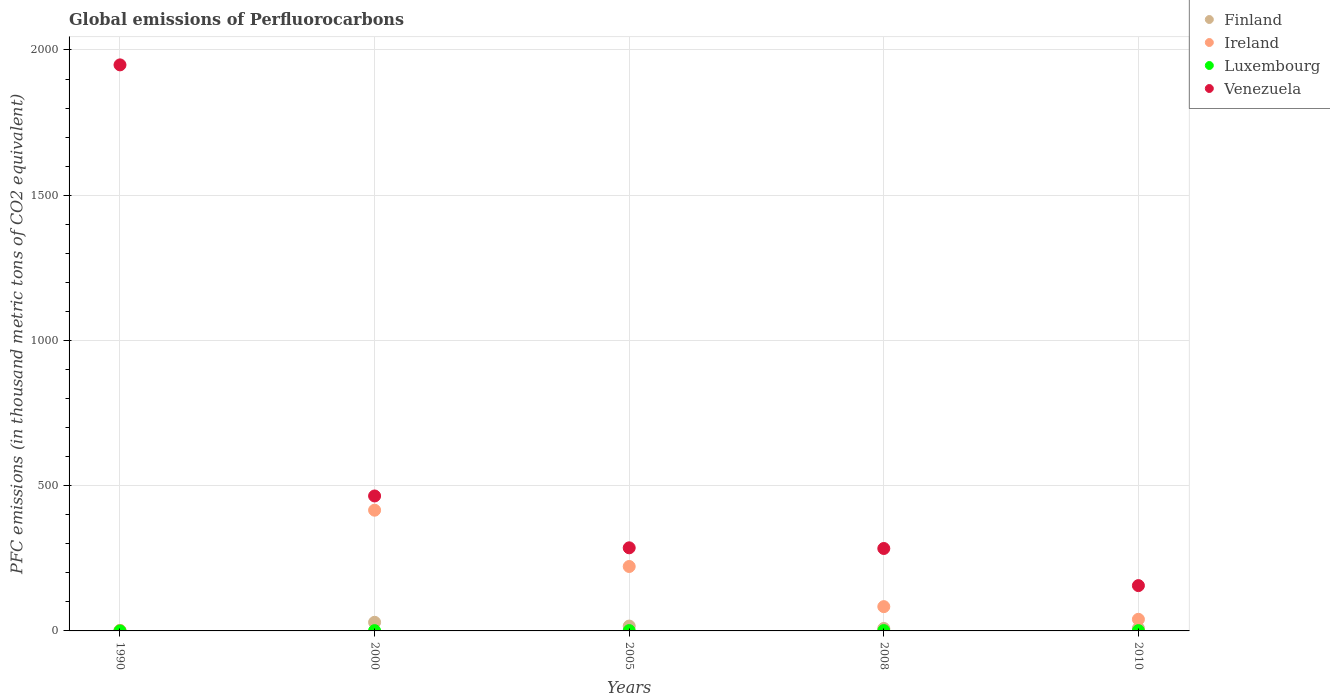What is the global emissions of Perfluorocarbons in Venezuela in 2010?
Keep it short and to the point. 156. Across all years, what is the maximum global emissions of Perfluorocarbons in Ireland?
Give a very brief answer. 415.6. In which year was the global emissions of Perfluorocarbons in Finland maximum?
Give a very brief answer. 2000. What is the total global emissions of Perfluorocarbons in Ireland in the graph?
Offer a terse response. 762.4. What is the difference between the global emissions of Perfluorocarbons in Luxembourg in 2000 and that in 2010?
Your response must be concise. 0. What is the difference between the global emissions of Perfluorocarbons in Venezuela in 2000 and the global emissions of Perfluorocarbons in Luxembourg in 1990?
Offer a very short reply. 464.5. What is the average global emissions of Perfluorocarbons in Finland per year?
Your answer should be very brief. 13.1. In how many years, is the global emissions of Perfluorocarbons in Venezuela greater than 400 thousand metric tons?
Keep it short and to the point. 2. What is the ratio of the global emissions of Perfluorocarbons in Venezuela in 2005 to that in 2010?
Offer a terse response. 1.83. What is the difference between the highest and the second highest global emissions of Perfluorocarbons in Luxembourg?
Give a very brief answer. 0.1. What is the difference between the highest and the lowest global emissions of Perfluorocarbons in Ireland?
Your answer should be very brief. 414.2. In how many years, is the global emissions of Perfluorocarbons in Ireland greater than the average global emissions of Perfluorocarbons in Ireland taken over all years?
Give a very brief answer. 2. Is it the case that in every year, the sum of the global emissions of Perfluorocarbons in Finland and global emissions of Perfluorocarbons in Ireland  is greater than the global emissions of Perfluorocarbons in Venezuela?
Ensure brevity in your answer.  No. How many dotlines are there?
Give a very brief answer. 4. What is the difference between two consecutive major ticks on the Y-axis?
Your answer should be very brief. 500. Are the values on the major ticks of Y-axis written in scientific E-notation?
Provide a succinct answer. No. Does the graph contain grids?
Ensure brevity in your answer.  Yes. Where does the legend appear in the graph?
Offer a terse response. Top right. How many legend labels are there?
Your answer should be compact. 4. How are the legend labels stacked?
Give a very brief answer. Vertical. What is the title of the graph?
Provide a succinct answer. Global emissions of Perfluorocarbons. What is the label or title of the Y-axis?
Provide a succinct answer. PFC emissions (in thousand metric tons of CO2 equivalent). What is the PFC emissions (in thousand metric tons of CO2 equivalent) of Luxembourg in 1990?
Provide a short and direct response. 0.1. What is the PFC emissions (in thousand metric tons of CO2 equivalent) in Venezuela in 1990?
Give a very brief answer. 1948.7. What is the PFC emissions (in thousand metric tons of CO2 equivalent) of Finland in 2000?
Keep it short and to the point. 29.7. What is the PFC emissions (in thousand metric tons of CO2 equivalent) in Ireland in 2000?
Your response must be concise. 415.6. What is the PFC emissions (in thousand metric tons of CO2 equivalent) in Venezuela in 2000?
Your answer should be very brief. 464.6. What is the PFC emissions (in thousand metric tons of CO2 equivalent) in Finland in 2005?
Your answer should be very brief. 16.7. What is the PFC emissions (in thousand metric tons of CO2 equivalent) of Ireland in 2005?
Offer a terse response. 221.8. What is the PFC emissions (in thousand metric tons of CO2 equivalent) in Venezuela in 2005?
Make the answer very short. 286.1. What is the PFC emissions (in thousand metric tons of CO2 equivalent) of Finland in 2008?
Make the answer very short. 8.4. What is the PFC emissions (in thousand metric tons of CO2 equivalent) in Ireland in 2008?
Your response must be concise. 83.6. What is the PFC emissions (in thousand metric tons of CO2 equivalent) of Luxembourg in 2008?
Make the answer very short. 1.2. What is the PFC emissions (in thousand metric tons of CO2 equivalent) of Venezuela in 2008?
Keep it short and to the point. 283.8. What is the PFC emissions (in thousand metric tons of CO2 equivalent) in Finland in 2010?
Provide a succinct answer. 9. What is the PFC emissions (in thousand metric tons of CO2 equivalent) in Ireland in 2010?
Your answer should be very brief. 40. What is the PFC emissions (in thousand metric tons of CO2 equivalent) in Venezuela in 2010?
Provide a succinct answer. 156. Across all years, what is the maximum PFC emissions (in thousand metric tons of CO2 equivalent) of Finland?
Provide a short and direct response. 29.7. Across all years, what is the maximum PFC emissions (in thousand metric tons of CO2 equivalent) of Ireland?
Offer a terse response. 415.6. Across all years, what is the maximum PFC emissions (in thousand metric tons of CO2 equivalent) of Luxembourg?
Provide a succinct answer. 1.2. Across all years, what is the maximum PFC emissions (in thousand metric tons of CO2 equivalent) in Venezuela?
Your response must be concise. 1948.7. Across all years, what is the minimum PFC emissions (in thousand metric tons of CO2 equivalent) of Finland?
Offer a very short reply. 1.7. Across all years, what is the minimum PFC emissions (in thousand metric tons of CO2 equivalent) in Luxembourg?
Keep it short and to the point. 0.1. Across all years, what is the minimum PFC emissions (in thousand metric tons of CO2 equivalent) in Venezuela?
Ensure brevity in your answer.  156. What is the total PFC emissions (in thousand metric tons of CO2 equivalent) in Finland in the graph?
Provide a short and direct response. 65.5. What is the total PFC emissions (in thousand metric tons of CO2 equivalent) in Ireland in the graph?
Keep it short and to the point. 762.4. What is the total PFC emissions (in thousand metric tons of CO2 equivalent) of Venezuela in the graph?
Provide a succinct answer. 3139.2. What is the difference between the PFC emissions (in thousand metric tons of CO2 equivalent) of Ireland in 1990 and that in 2000?
Keep it short and to the point. -414.2. What is the difference between the PFC emissions (in thousand metric tons of CO2 equivalent) in Luxembourg in 1990 and that in 2000?
Ensure brevity in your answer.  -0.9. What is the difference between the PFC emissions (in thousand metric tons of CO2 equivalent) of Venezuela in 1990 and that in 2000?
Offer a terse response. 1484.1. What is the difference between the PFC emissions (in thousand metric tons of CO2 equivalent) in Finland in 1990 and that in 2005?
Make the answer very short. -15. What is the difference between the PFC emissions (in thousand metric tons of CO2 equivalent) of Ireland in 1990 and that in 2005?
Provide a succinct answer. -220.4. What is the difference between the PFC emissions (in thousand metric tons of CO2 equivalent) in Luxembourg in 1990 and that in 2005?
Offer a very short reply. -1. What is the difference between the PFC emissions (in thousand metric tons of CO2 equivalent) in Venezuela in 1990 and that in 2005?
Offer a terse response. 1662.6. What is the difference between the PFC emissions (in thousand metric tons of CO2 equivalent) of Ireland in 1990 and that in 2008?
Ensure brevity in your answer.  -82.2. What is the difference between the PFC emissions (in thousand metric tons of CO2 equivalent) in Venezuela in 1990 and that in 2008?
Ensure brevity in your answer.  1664.9. What is the difference between the PFC emissions (in thousand metric tons of CO2 equivalent) in Ireland in 1990 and that in 2010?
Make the answer very short. -38.6. What is the difference between the PFC emissions (in thousand metric tons of CO2 equivalent) of Venezuela in 1990 and that in 2010?
Keep it short and to the point. 1792.7. What is the difference between the PFC emissions (in thousand metric tons of CO2 equivalent) in Ireland in 2000 and that in 2005?
Your answer should be compact. 193.8. What is the difference between the PFC emissions (in thousand metric tons of CO2 equivalent) in Luxembourg in 2000 and that in 2005?
Offer a terse response. -0.1. What is the difference between the PFC emissions (in thousand metric tons of CO2 equivalent) in Venezuela in 2000 and that in 2005?
Your answer should be compact. 178.5. What is the difference between the PFC emissions (in thousand metric tons of CO2 equivalent) of Finland in 2000 and that in 2008?
Offer a terse response. 21.3. What is the difference between the PFC emissions (in thousand metric tons of CO2 equivalent) of Ireland in 2000 and that in 2008?
Offer a very short reply. 332. What is the difference between the PFC emissions (in thousand metric tons of CO2 equivalent) of Luxembourg in 2000 and that in 2008?
Provide a succinct answer. -0.2. What is the difference between the PFC emissions (in thousand metric tons of CO2 equivalent) in Venezuela in 2000 and that in 2008?
Ensure brevity in your answer.  180.8. What is the difference between the PFC emissions (in thousand metric tons of CO2 equivalent) of Finland in 2000 and that in 2010?
Keep it short and to the point. 20.7. What is the difference between the PFC emissions (in thousand metric tons of CO2 equivalent) of Ireland in 2000 and that in 2010?
Make the answer very short. 375.6. What is the difference between the PFC emissions (in thousand metric tons of CO2 equivalent) in Venezuela in 2000 and that in 2010?
Your answer should be very brief. 308.6. What is the difference between the PFC emissions (in thousand metric tons of CO2 equivalent) of Finland in 2005 and that in 2008?
Provide a succinct answer. 8.3. What is the difference between the PFC emissions (in thousand metric tons of CO2 equivalent) in Ireland in 2005 and that in 2008?
Offer a terse response. 138.2. What is the difference between the PFC emissions (in thousand metric tons of CO2 equivalent) in Venezuela in 2005 and that in 2008?
Keep it short and to the point. 2.3. What is the difference between the PFC emissions (in thousand metric tons of CO2 equivalent) of Finland in 2005 and that in 2010?
Offer a terse response. 7.7. What is the difference between the PFC emissions (in thousand metric tons of CO2 equivalent) of Ireland in 2005 and that in 2010?
Offer a terse response. 181.8. What is the difference between the PFC emissions (in thousand metric tons of CO2 equivalent) of Luxembourg in 2005 and that in 2010?
Give a very brief answer. 0.1. What is the difference between the PFC emissions (in thousand metric tons of CO2 equivalent) in Venezuela in 2005 and that in 2010?
Make the answer very short. 130.1. What is the difference between the PFC emissions (in thousand metric tons of CO2 equivalent) in Ireland in 2008 and that in 2010?
Offer a very short reply. 43.6. What is the difference between the PFC emissions (in thousand metric tons of CO2 equivalent) in Venezuela in 2008 and that in 2010?
Make the answer very short. 127.8. What is the difference between the PFC emissions (in thousand metric tons of CO2 equivalent) of Finland in 1990 and the PFC emissions (in thousand metric tons of CO2 equivalent) of Ireland in 2000?
Offer a terse response. -413.9. What is the difference between the PFC emissions (in thousand metric tons of CO2 equivalent) of Finland in 1990 and the PFC emissions (in thousand metric tons of CO2 equivalent) of Venezuela in 2000?
Offer a terse response. -462.9. What is the difference between the PFC emissions (in thousand metric tons of CO2 equivalent) of Ireland in 1990 and the PFC emissions (in thousand metric tons of CO2 equivalent) of Luxembourg in 2000?
Make the answer very short. 0.4. What is the difference between the PFC emissions (in thousand metric tons of CO2 equivalent) in Ireland in 1990 and the PFC emissions (in thousand metric tons of CO2 equivalent) in Venezuela in 2000?
Offer a very short reply. -463.2. What is the difference between the PFC emissions (in thousand metric tons of CO2 equivalent) in Luxembourg in 1990 and the PFC emissions (in thousand metric tons of CO2 equivalent) in Venezuela in 2000?
Make the answer very short. -464.5. What is the difference between the PFC emissions (in thousand metric tons of CO2 equivalent) of Finland in 1990 and the PFC emissions (in thousand metric tons of CO2 equivalent) of Ireland in 2005?
Your answer should be very brief. -220.1. What is the difference between the PFC emissions (in thousand metric tons of CO2 equivalent) in Finland in 1990 and the PFC emissions (in thousand metric tons of CO2 equivalent) in Venezuela in 2005?
Your response must be concise. -284.4. What is the difference between the PFC emissions (in thousand metric tons of CO2 equivalent) in Ireland in 1990 and the PFC emissions (in thousand metric tons of CO2 equivalent) in Luxembourg in 2005?
Your response must be concise. 0.3. What is the difference between the PFC emissions (in thousand metric tons of CO2 equivalent) in Ireland in 1990 and the PFC emissions (in thousand metric tons of CO2 equivalent) in Venezuela in 2005?
Give a very brief answer. -284.7. What is the difference between the PFC emissions (in thousand metric tons of CO2 equivalent) of Luxembourg in 1990 and the PFC emissions (in thousand metric tons of CO2 equivalent) of Venezuela in 2005?
Ensure brevity in your answer.  -286. What is the difference between the PFC emissions (in thousand metric tons of CO2 equivalent) of Finland in 1990 and the PFC emissions (in thousand metric tons of CO2 equivalent) of Ireland in 2008?
Ensure brevity in your answer.  -81.9. What is the difference between the PFC emissions (in thousand metric tons of CO2 equivalent) in Finland in 1990 and the PFC emissions (in thousand metric tons of CO2 equivalent) in Luxembourg in 2008?
Make the answer very short. 0.5. What is the difference between the PFC emissions (in thousand metric tons of CO2 equivalent) in Finland in 1990 and the PFC emissions (in thousand metric tons of CO2 equivalent) in Venezuela in 2008?
Provide a succinct answer. -282.1. What is the difference between the PFC emissions (in thousand metric tons of CO2 equivalent) in Ireland in 1990 and the PFC emissions (in thousand metric tons of CO2 equivalent) in Luxembourg in 2008?
Offer a terse response. 0.2. What is the difference between the PFC emissions (in thousand metric tons of CO2 equivalent) of Ireland in 1990 and the PFC emissions (in thousand metric tons of CO2 equivalent) of Venezuela in 2008?
Ensure brevity in your answer.  -282.4. What is the difference between the PFC emissions (in thousand metric tons of CO2 equivalent) of Luxembourg in 1990 and the PFC emissions (in thousand metric tons of CO2 equivalent) of Venezuela in 2008?
Provide a short and direct response. -283.7. What is the difference between the PFC emissions (in thousand metric tons of CO2 equivalent) of Finland in 1990 and the PFC emissions (in thousand metric tons of CO2 equivalent) of Ireland in 2010?
Give a very brief answer. -38.3. What is the difference between the PFC emissions (in thousand metric tons of CO2 equivalent) of Finland in 1990 and the PFC emissions (in thousand metric tons of CO2 equivalent) of Venezuela in 2010?
Offer a terse response. -154.3. What is the difference between the PFC emissions (in thousand metric tons of CO2 equivalent) in Ireland in 1990 and the PFC emissions (in thousand metric tons of CO2 equivalent) in Venezuela in 2010?
Offer a very short reply. -154.6. What is the difference between the PFC emissions (in thousand metric tons of CO2 equivalent) in Luxembourg in 1990 and the PFC emissions (in thousand metric tons of CO2 equivalent) in Venezuela in 2010?
Provide a short and direct response. -155.9. What is the difference between the PFC emissions (in thousand metric tons of CO2 equivalent) of Finland in 2000 and the PFC emissions (in thousand metric tons of CO2 equivalent) of Ireland in 2005?
Offer a terse response. -192.1. What is the difference between the PFC emissions (in thousand metric tons of CO2 equivalent) of Finland in 2000 and the PFC emissions (in thousand metric tons of CO2 equivalent) of Luxembourg in 2005?
Make the answer very short. 28.6. What is the difference between the PFC emissions (in thousand metric tons of CO2 equivalent) of Finland in 2000 and the PFC emissions (in thousand metric tons of CO2 equivalent) of Venezuela in 2005?
Give a very brief answer. -256.4. What is the difference between the PFC emissions (in thousand metric tons of CO2 equivalent) in Ireland in 2000 and the PFC emissions (in thousand metric tons of CO2 equivalent) in Luxembourg in 2005?
Provide a succinct answer. 414.5. What is the difference between the PFC emissions (in thousand metric tons of CO2 equivalent) of Ireland in 2000 and the PFC emissions (in thousand metric tons of CO2 equivalent) of Venezuela in 2005?
Ensure brevity in your answer.  129.5. What is the difference between the PFC emissions (in thousand metric tons of CO2 equivalent) of Luxembourg in 2000 and the PFC emissions (in thousand metric tons of CO2 equivalent) of Venezuela in 2005?
Give a very brief answer. -285.1. What is the difference between the PFC emissions (in thousand metric tons of CO2 equivalent) of Finland in 2000 and the PFC emissions (in thousand metric tons of CO2 equivalent) of Ireland in 2008?
Your response must be concise. -53.9. What is the difference between the PFC emissions (in thousand metric tons of CO2 equivalent) in Finland in 2000 and the PFC emissions (in thousand metric tons of CO2 equivalent) in Luxembourg in 2008?
Provide a succinct answer. 28.5. What is the difference between the PFC emissions (in thousand metric tons of CO2 equivalent) of Finland in 2000 and the PFC emissions (in thousand metric tons of CO2 equivalent) of Venezuela in 2008?
Offer a very short reply. -254.1. What is the difference between the PFC emissions (in thousand metric tons of CO2 equivalent) in Ireland in 2000 and the PFC emissions (in thousand metric tons of CO2 equivalent) in Luxembourg in 2008?
Provide a short and direct response. 414.4. What is the difference between the PFC emissions (in thousand metric tons of CO2 equivalent) of Ireland in 2000 and the PFC emissions (in thousand metric tons of CO2 equivalent) of Venezuela in 2008?
Ensure brevity in your answer.  131.8. What is the difference between the PFC emissions (in thousand metric tons of CO2 equivalent) in Luxembourg in 2000 and the PFC emissions (in thousand metric tons of CO2 equivalent) in Venezuela in 2008?
Provide a short and direct response. -282.8. What is the difference between the PFC emissions (in thousand metric tons of CO2 equivalent) in Finland in 2000 and the PFC emissions (in thousand metric tons of CO2 equivalent) in Ireland in 2010?
Offer a very short reply. -10.3. What is the difference between the PFC emissions (in thousand metric tons of CO2 equivalent) of Finland in 2000 and the PFC emissions (in thousand metric tons of CO2 equivalent) of Luxembourg in 2010?
Ensure brevity in your answer.  28.7. What is the difference between the PFC emissions (in thousand metric tons of CO2 equivalent) in Finland in 2000 and the PFC emissions (in thousand metric tons of CO2 equivalent) in Venezuela in 2010?
Give a very brief answer. -126.3. What is the difference between the PFC emissions (in thousand metric tons of CO2 equivalent) in Ireland in 2000 and the PFC emissions (in thousand metric tons of CO2 equivalent) in Luxembourg in 2010?
Make the answer very short. 414.6. What is the difference between the PFC emissions (in thousand metric tons of CO2 equivalent) in Ireland in 2000 and the PFC emissions (in thousand metric tons of CO2 equivalent) in Venezuela in 2010?
Your answer should be very brief. 259.6. What is the difference between the PFC emissions (in thousand metric tons of CO2 equivalent) in Luxembourg in 2000 and the PFC emissions (in thousand metric tons of CO2 equivalent) in Venezuela in 2010?
Offer a very short reply. -155. What is the difference between the PFC emissions (in thousand metric tons of CO2 equivalent) in Finland in 2005 and the PFC emissions (in thousand metric tons of CO2 equivalent) in Ireland in 2008?
Offer a very short reply. -66.9. What is the difference between the PFC emissions (in thousand metric tons of CO2 equivalent) of Finland in 2005 and the PFC emissions (in thousand metric tons of CO2 equivalent) of Luxembourg in 2008?
Provide a succinct answer. 15.5. What is the difference between the PFC emissions (in thousand metric tons of CO2 equivalent) in Finland in 2005 and the PFC emissions (in thousand metric tons of CO2 equivalent) in Venezuela in 2008?
Ensure brevity in your answer.  -267.1. What is the difference between the PFC emissions (in thousand metric tons of CO2 equivalent) in Ireland in 2005 and the PFC emissions (in thousand metric tons of CO2 equivalent) in Luxembourg in 2008?
Make the answer very short. 220.6. What is the difference between the PFC emissions (in thousand metric tons of CO2 equivalent) in Ireland in 2005 and the PFC emissions (in thousand metric tons of CO2 equivalent) in Venezuela in 2008?
Offer a terse response. -62. What is the difference between the PFC emissions (in thousand metric tons of CO2 equivalent) in Luxembourg in 2005 and the PFC emissions (in thousand metric tons of CO2 equivalent) in Venezuela in 2008?
Offer a very short reply. -282.7. What is the difference between the PFC emissions (in thousand metric tons of CO2 equivalent) in Finland in 2005 and the PFC emissions (in thousand metric tons of CO2 equivalent) in Ireland in 2010?
Your response must be concise. -23.3. What is the difference between the PFC emissions (in thousand metric tons of CO2 equivalent) of Finland in 2005 and the PFC emissions (in thousand metric tons of CO2 equivalent) of Luxembourg in 2010?
Keep it short and to the point. 15.7. What is the difference between the PFC emissions (in thousand metric tons of CO2 equivalent) in Finland in 2005 and the PFC emissions (in thousand metric tons of CO2 equivalent) in Venezuela in 2010?
Give a very brief answer. -139.3. What is the difference between the PFC emissions (in thousand metric tons of CO2 equivalent) in Ireland in 2005 and the PFC emissions (in thousand metric tons of CO2 equivalent) in Luxembourg in 2010?
Your answer should be compact. 220.8. What is the difference between the PFC emissions (in thousand metric tons of CO2 equivalent) in Ireland in 2005 and the PFC emissions (in thousand metric tons of CO2 equivalent) in Venezuela in 2010?
Offer a terse response. 65.8. What is the difference between the PFC emissions (in thousand metric tons of CO2 equivalent) of Luxembourg in 2005 and the PFC emissions (in thousand metric tons of CO2 equivalent) of Venezuela in 2010?
Ensure brevity in your answer.  -154.9. What is the difference between the PFC emissions (in thousand metric tons of CO2 equivalent) in Finland in 2008 and the PFC emissions (in thousand metric tons of CO2 equivalent) in Ireland in 2010?
Provide a succinct answer. -31.6. What is the difference between the PFC emissions (in thousand metric tons of CO2 equivalent) of Finland in 2008 and the PFC emissions (in thousand metric tons of CO2 equivalent) of Venezuela in 2010?
Provide a succinct answer. -147.6. What is the difference between the PFC emissions (in thousand metric tons of CO2 equivalent) in Ireland in 2008 and the PFC emissions (in thousand metric tons of CO2 equivalent) in Luxembourg in 2010?
Your answer should be compact. 82.6. What is the difference between the PFC emissions (in thousand metric tons of CO2 equivalent) in Ireland in 2008 and the PFC emissions (in thousand metric tons of CO2 equivalent) in Venezuela in 2010?
Offer a very short reply. -72.4. What is the difference between the PFC emissions (in thousand metric tons of CO2 equivalent) in Luxembourg in 2008 and the PFC emissions (in thousand metric tons of CO2 equivalent) in Venezuela in 2010?
Offer a very short reply. -154.8. What is the average PFC emissions (in thousand metric tons of CO2 equivalent) in Ireland per year?
Your response must be concise. 152.48. What is the average PFC emissions (in thousand metric tons of CO2 equivalent) in Venezuela per year?
Your answer should be compact. 627.84. In the year 1990, what is the difference between the PFC emissions (in thousand metric tons of CO2 equivalent) of Finland and PFC emissions (in thousand metric tons of CO2 equivalent) of Ireland?
Keep it short and to the point. 0.3. In the year 1990, what is the difference between the PFC emissions (in thousand metric tons of CO2 equivalent) of Finland and PFC emissions (in thousand metric tons of CO2 equivalent) of Venezuela?
Your answer should be compact. -1947. In the year 1990, what is the difference between the PFC emissions (in thousand metric tons of CO2 equivalent) in Ireland and PFC emissions (in thousand metric tons of CO2 equivalent) in Venezuela?
Offer a very short reply. -1947.3. In the year 1990, what is the difference between the PFC emissions (in thousand metric tons of CO2 equivalent) in Luxembourg and PFC emissions (in thousand metric tons of CO2 equivalent) in Venezuela?
Keep it short and to the point. -1948.6. In the year 2000, what is the difference between the PFC emissions (in thousand metric tons of CO2 equivalent) of Finland and PFC emissions (in thousand metric tons of CO2 equivalent) of Ireland?
Provide a succinct answer. -385.9. In the year 2000, what is the difference between the PFC emissions (in thousand metric tons of CO2 equivalent) of Finland and PFC emissions (in thousand metric tons of CO2 equivalent) of Luxembourg?
Make the answer very short. 28.7. In the year 2000, what is the difference between the PFC emissions (in thousand metric tons of CO2 equivalent) of Finland and PFC emissions (in thousand metric tons of CO2 equivalent) of Venezuela?
Keep it short and to the point. -434.9. In the year 2000, what is the difference between the PFC emissions (in thousand metric tons of CO2 equivalent) of Ireland and PFC emissions (in thousand metric tons of CO2 equivalent) of Luxembourg?
Your response must be concise. 414.6. In the year 2000, what is the difference between the PFC emissions (in thousand metric tons of CO2 equivalent) in Ireland and PFC emissions (in thousand metric tons of CO2 equivalent) in Venezuela?
Provide a short and direct response. -49. In the year 2000, what is the difference between the PFC emissions (in thousand metric tons of CO2 equivalent) in Luxembourg and PFC emissions (in thousand metric tons of CO2 equivalent) in Venezuela?
Provide a short and direct response. -463.6. In the year 2005, what is the difference between the PFC emissions (in thousand metric tons of CO2 equivalent) of Finland and PFC emissions (in thousand metric tons of CO2 equivalent) of Ireland?
Ensure brevity in your answer.  -205.1. In the year 2005, what is the difference between the PFC emissions (in thousand metric tons of CO2 equivalent) in Finland and PFC emissions (in thousand metric tons of CO2 equivalent) in Venezuela?
Offer a terse response. -269.4. In the year 2005, what is the difference between the PFC emissions (in thousand metric tons of CO2 equivalent) of Ireland and PFC emissions (in thousand metric tons of CO2 equivalent) of Luxembourg?
Keep it short and to the point. 220.7. In the year 2005, what is the difference between the PFC emissions (in thousand metric tons of CO2 equivalent) of Ireland and PFC emissions (in thousand metric tons of CO2 equivalent) of Venezuela?
Your response must be concise. -64.3. In the year 2005, what is the difference between the PFC emissions (in thousand metric tons of CO2 equivalent) in Luxembourg and PFC emissions (in thousand metric tons of CO2 equivalent) in Venezuela?
Make the answer very short. -285. In the year 2008, what is the difference between the PFC emissions (in thousand metric tons of CO2 equivalent) in Finland and PFC emissions (in thousand metric tons of CO2 equivalent) in Ireland?
Keep it short and to the point. -75.2. In the year 2008, what is the difference between the PFC emissions (in thousand metric tons of CO2 equivalent) of Finland and PFC emissions (in thousand metric tons of CO2 equivalent) of Luxembourg?
Your answer should be compact. 7.2. In the year 2008, what is the difference between the PFC emissions (in thousand metric tons of CO2 equivalent) in Finland and PFC emissions (in thousand metric tons of CO2 equivalent) in Venezuela?
Your response must be concise. -275.4. In the year 2008, what is the difference between the PFC emissions (in thousand metric tons of CO2 equivalent) in Ireland and PFC emissions (in thousand metric tons of CO2 equivalent) in Luxembourg?
Offer a terse response. 82.4. In the year 2008, what is the difference between the PFC emissions (in thousand metric tons of CO2 equivalent) in Ireland and PFC emissions (in thousand metric tons of CO2 equivalent) in Venezuela?
Offer a terse response. -200.2. In the year 2008, what is the difference between the PFC emissions (in thousand metric tons of CO2 equivalent) of Luxembourg and PFC emissions (in thousand metric tons of CO2 equivalent) of Venezuela?
Ensure brevity in your answer.  -282.6. In the year 2010, what is the difference between the PFC emissions (in thousand metric tons of CO2 equivalent) of Finland and PFC emissions (in thousand metric tons of CO2 equivalent) of Ireland?
Make the answer very short. -31. In the year 2010, what is the difference between the PFC emissions (in thousand metric tons of CO2 equivalent) of Finland and PFC emissions (in thousand metric tons of CO2 equivalent) of Venezuela?
Provide a succinct answer. -147. In the year 2010, what is the difference between the PFC emissions (in thousand metric tons of CO2 equivalent) in Ireland and PFC emissions (in thousand metric tons of CO2 equivalent) in Venezuela?
Provide a succinct answer. -116. In the year 2010, what is the difference between the PFC emissions (in thousand metric tons of CO2 equivalent) in Luxembourg and PFC emissions (in thousand metric tons of CO2 equivalent) in Venezuela?
Give a very brief answer. -155. What is the ratio of the PFC emissions (in thousand metric tons of CO2 equivalent) of Finland in 1990 to that in 2000?
Keep it short and to the point. 0.06. What is the ratio of the PFC emissions (in thousand metric tons of CO2 equivalent) of Ireland in 1990 to that in 2000?
Your answer should be very brief. 0. What is the ratio of the PFC emissions (in thousand metric tons of CO2 equivalent) in Venezuela in 1990 to that in 2000?
Offer a terse response. 4.19. What is the ratio of the PFC emissions (in thousand metric tons of CO2 equivalent) of Finland in 1990 to that in 2005?
Your answer should be compact. 0.1. What is the ratio of the PFC emissions (in thousand metric tons of CO2 equivalent) of Ireland in 1990 to that in 2005?
Offer a very short reply. 0.01. What is the ratio of the PFC emissions (in thousand metric tons of CO2 equivalent) in Luxembourg in 1990 to that in 2005?
Offer a terse response. 0.09. What is the ratio of the PFC emissions (in thousand metric tons of CO2 equivalent) in Venezuela in 1990 to that in 2005?
Keep it short and to the point. 6.81. What is the ratio of the PFC emissions (in thousand metric tons of CO2 equivalent) in Finland in 1990 to that in 2008?
Give a very brief answer. 0.2. What is the ratio of the PFC emissions (in thousand metric tons of CO2 equivalent) in Ireland in 1990 to that in 2008?
Provide a succinct answer. 0.02. What is the ratio of the PFC emissions (in thousand metric tons of CO2 equivalent) in Luxembourg in 1990 to that in 2008?
Provide a short and direct response. 0.08. What is the ratio of the PFC emissions (in thousand metric tons of CO2 equivalent) in Venezuela in 1990 to that in 2008?
Keep it short and to the point. 6.87. What is the ratio of the PFC emissions (in thousand metric tons of CO2 equivalent) of Finland in 1990 to that in 2010?
Ensure brevity in your answer.  0.19. What is the ratio of the PFC emissions (in thousand metric tons of CO2 equivalent) in Ireland in 1990 to that in 2010?
Provide a succinct answer. 0.04. What is the ratio of the PFC emissions (in thousand metric tons of CO2 equivalent) of Luxembourg in 1990 to that in 2010?
Ensure brevity in your answer.  0.1. What is the ratio of the PFC emissions (in thousand metric tons of CO2 equivalent) in Venezuela in 1990 to that in 2010?
Your answer should be very brief. 12.49. What is the ratio of the PFC emissions (in thousand metric tons of CO2 equivalent) of Finland in 2000 to that in 2005?
Ensure brevity in your answer.  1.78. What is the ratio of the PFC emissions (in thousand metric tons of CO2 equivalent) of Ireland in 2000 to that in 2005?
Your response must be concise. 1.87. What is the ratio of the PFC emissions (in thousand metric tons of CO2 equivalent) of Luxembourg in 2000 to that in 2005?
Give a very brief answer. 0.91. What is the ratio of the PFC emissions (in thousand metric tons of CO2 equivalent) in Venezuela in 2000 to that in 2005?
Provide a succinct answer. 1.62. What is the ratio of the PFC emissions (in thousand metric tons of CO2 equivalent) in Finland in 2000 to that in 2008?
Keep it short and to the point. 3.54. What is the ratio of the PFC emissions (in thousand metric tons of CO2 equivalent) in Ireland in 2000 to that in 2008?
Your response must be concise. 4.97. What is the ratio of the PFC emissions (in thousand metric tons of CO2 equivalent) of Venezuela in 2000 to that in 2008?
Offer a very short reply. 1.64. What is the ratio of the PFC emissions (in thousand metric tons of CO2 equivalent) of Finland in 2000 to that in 2010?
Ensure brevity in your answer.  3.3. What is the ratio of the PFC emissions (in thousand metric tons of CO2 equivalent) in Ireland in 2000 to that in 2010?
Your answer should be very brief. 10.39. What is the ratio of the PFC emissions (in thousand metric tons of CO2 equivalent) in Venezuela in 2000 to that in 2010?
Provide a succinct answer. 2.98. What is the ratio of the PFC emissions (in thousand metric tons of CO2 equivalent) of Finland in 2005 to that in 2008?
Your answer should be very brief. 1.99. What is the ratio of the PFC emissions (in thousand metric tons of CO2 equivalent) in Ireland in 2005 to that in 2008?
Give a very brief answer. 2.65. What is the ratio of the PFC emissions (in thousand metric tons of CO2 equivalent) of Luxembourg in 2005 to that in 2008?
Make the answer very short. 0.92. What is the ratio of the PFC emissions (in thousand metric tons of CO2 equivalent) in Finland in 2005 to that in 2010?
Keep it short and to the point. 1.86. What is the ratio of the PFC emissions (in thousand metric tons of CO2 equivalent) of Ireland in 2005 to that in 2010?
Make the answer very short. 5.54. What is the ratio of the PFC emissions (in thousand metric tons of CO2 equivalent) in Venezuela in 2005 to that in 2010?
Give a very brief answer. 1.83. What is the ratio of the PFC emissions (in thousand metric tons of CO2 equivalent) in Ireland in 2008 to that in 2010?
Provide a short and direct response. 2.09. What is the ratio of the PFC emissions (in thousand metric tons of CO2 equivalent) of Venezuela in 2008 to that in 2010?
Your answer should be very brief. 1.82. What is the difference between the highest and the second highest PFC emissions (in thousand metric tons of CO2 equivalent) in Finland?
Provide a succinct answer. 13. What is the difference between the highest and the second highest PFC emissions (in thousand metric tons of CO2 equivalent) of Ireland?
Give a very brief answer. 193.8. What is the difference between the highest and the second highest PFC emissions (in thousand metric tons of CO2 equivalent) of Venezuela?
Offer a terse response. 1484.1. What is the difference between the highest and the lowest PFC emissions (in thousand metric tons of CO2 equivalent) in Ireland?
Provide a succinct answer. 414.2. What is the difference between the highest and the lowest PFC emissions (in thousand metric tons of CO2 equivalent) in Luxembourg?
Ensure brevity in your answer.  1.1. What is the difference between the highest and the lowest PFC emissions (in thousand metric tons of CO2 equivalent) of Venezuela?
Ensure brevity in your answer.  1792.7. 